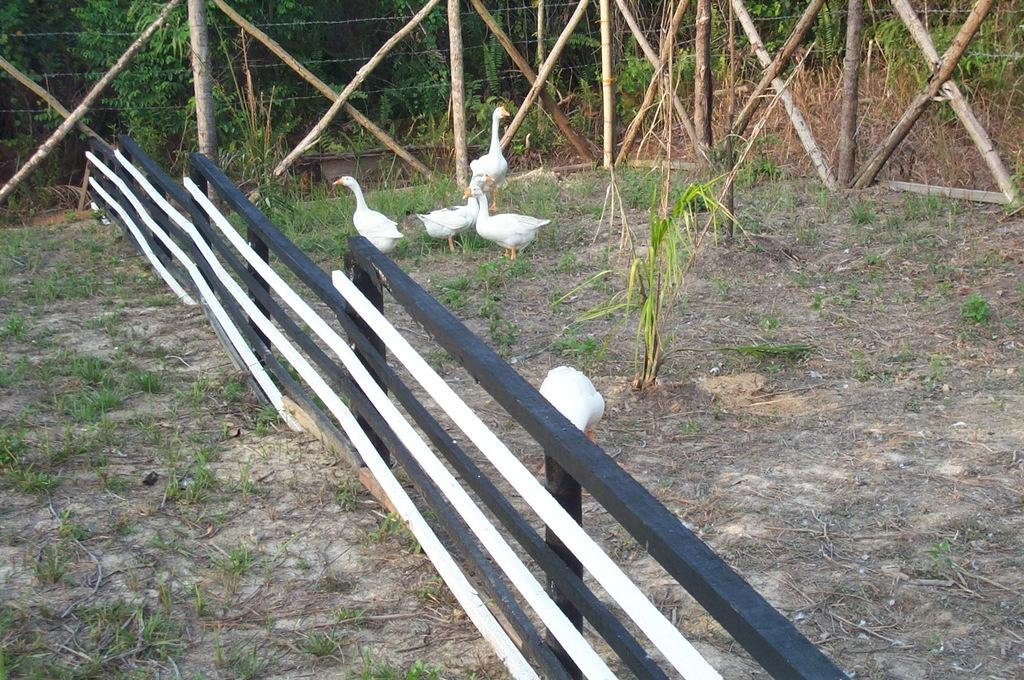What animals can be seen in the image? There are swans in the image. What type of structure is present in the image? There is a fence in the image. What type of vegetation is visible in the image? There are plants in the image. What can be seen in the background of the image? There are trees in the background of the image. What level of noise is the kitty making in the image? There is no kitty present in the image, so it is not possible to determine the level of noise it might be making. 